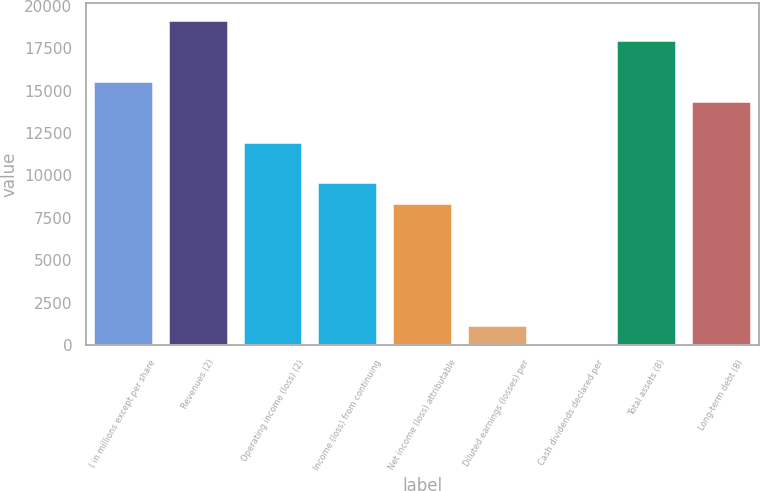Convert chart to OTSL. <chart><loc_0><loc_0><loc_500><loc_500><bar_chart><fcel>( in millions except per share<fcel>Revenues (2)<fcel>Operating income (loss) (2)<fcel>Income (loss) from continuing<fcel>Net income (loss) attributable<fcel>Diluted earnings (losses) per<fcel>Cash dividends declared per<fcel>Total assets (8)<fcel>Long-term debt (8)<nl><fcel>15593.5<fcel>19191.9<fcel>11995<fcel>9596.08<fcel>8396.6<fcel>1199.72<fcel>0.24<fcel>17992.4<fcel>14394<nl></chart> 